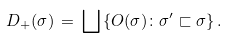Convert formula to latex. <formula><loc_0><loc_0><loc_500><loc_500>D _ { + } ( \sigma ) \, = \, \bigsqcup \left \{ O ( \sigma ) \colon \sigma ^ { \prime } \sqsubset \sigma \right \} .</formula> 